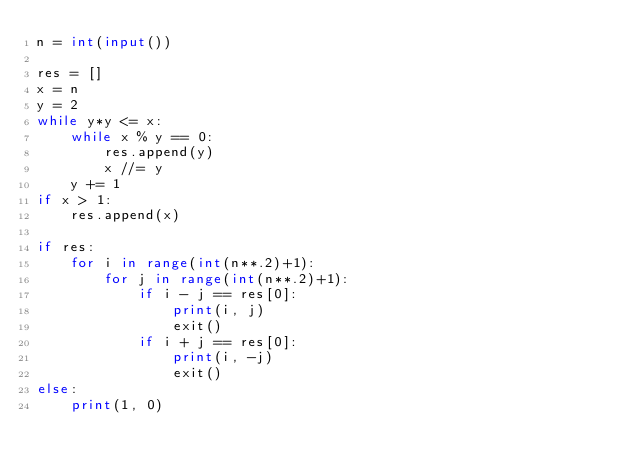<code> <loc_0><loc_0><loc_500><loc_500><_Python_>n = int(input())

res = []
x = n
y = 2
while y*y <= x:
    while x % y == 0:
        res.append(y)
        x //= y
    y += 1
if x > 1:
    res.append(x)

if res:
    for i in range(int(n**.2)+1):
        for j in range(int(n**.2)+1):
            if i - j == res[0]:
                print(i, j)
                exit()
            if i + j == res[0]:
                print(i, -j)
                exit()
else:
    print(1, 0)</code> 